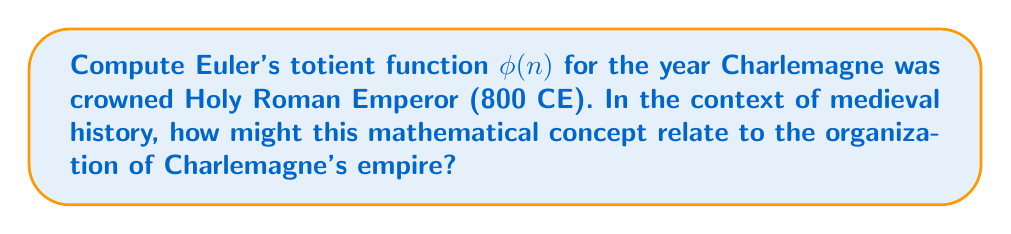Teach me how to tackle this problem. To compute Euler's totient function $\phi(800)$, we follow these steps:

1) First, factor 800 into its prime factors:
   $800 = 2^5 \times 5^2$

2) For a prime power $p^k$, the totient function is given by:
   $\phi(p^k) = p^k - p^{k-1} = p^k(1 - \frac{1}{p})$

3) For 800, we have two prime powers: $2^5$ and $5^2$

4) Calculate $\phi(2^5)$:
   $\phi(2^5) = 2^5 - 2^4 = 32 - 16 = 16$

5) Calculate $\phi(5^2)$:
   $\phi(5^2) = 5^2 - 5^1 = 25 - 5 = 20$

6) Since 800 is a product of coprime factors, we can use the multiplicative property of the totient function:
   $\phi(ab) = \phi(a) \times \phi(b)$ when $a$ and $b$ are coprime

7) Therefore:
   $\phi(800) = \phi(2^5) \times \phi(5^2) = 16 \times 20 = 320$

In the context of Charlemagne's empire, this mathematical concept could be related to the organization of his administrative system. The totient function counts the numbers up to n that are coprime to n, which could represent the number of potential local governors or officials that could be appointed without conflicting hierarchies in a system of 800 administrative units.
Answer: $\phi(800) = 320$ 